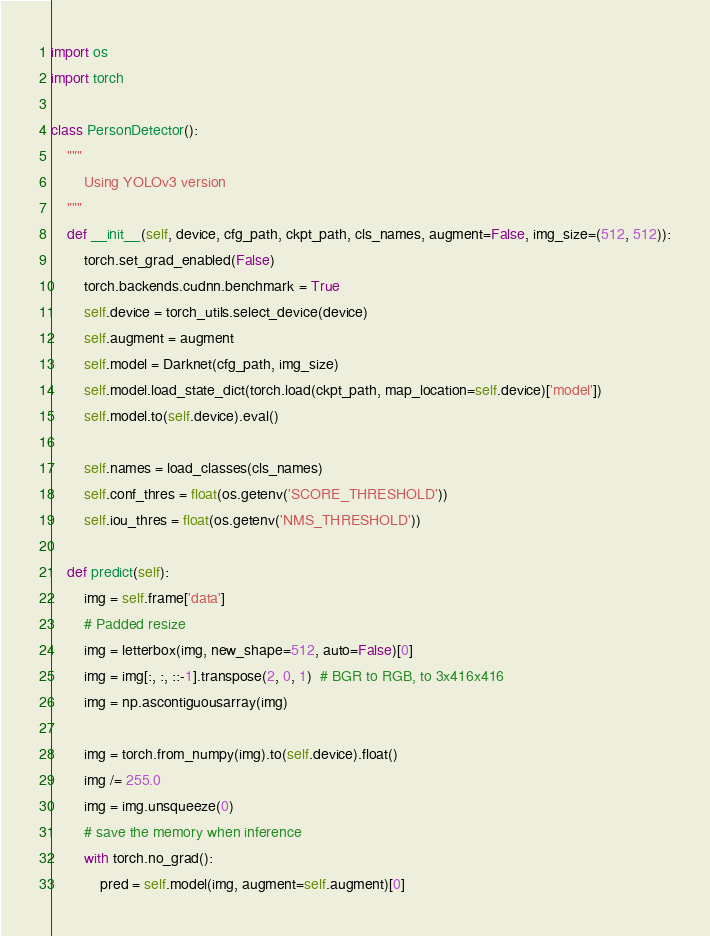Convert code to text. <code><loc_0><loc_0><loc_500><loc_500><_Python_>import os
import torch

class PersonDetector():
    """
        Using YOLOv3 version
    """
    def __init__(self, device, cfg_path, ckpt_path, cls_names, augment=False, img_size=(512, 512)):
        torch.set_grad_enabled(False)
        torch.backends.cudnn.benchmark = True
        self.device = torch_utils.select_device(device)
        self.augment = augment
        self.model = Darknet(cfg_path, img_size)
        self.model.load_state_dict(torch.load(ckpt_path, map_location=self.device)['model'])
        self.model.to(self.device).eval()

        self.names = load_classes(cls_names)
        self.conf_thres = float(os.getenv('SCORE_THRESHOLD'))
        self.iou_thres = float(os.getenv('NMS_THRESHOLD'))

    def predict(self):
        img = self.frame['data']
        # Padded resize
        img = letterbox(img, new_shape=512, auto=False)[0]
        img = img[:, :, ::-1].transpose(2, 0, 1)  # BGR to RGB, to 3x416x416
        img = np.ascontiguousarray(img)

        img = torch.from_numpy(img).to(self.device).float()
        img /= 255.0
        img = img.unsqueeze(0)
        # save the memory when inference
        with torch.no_grad():
            pred = self.model(img, augment=self.augment)[0]</code> 